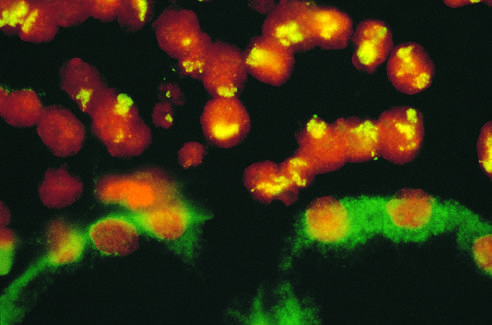do the photomicrographs show no nuclear staining and background cytoplasmic staining?
Answer the question using a single word or phrase. No 